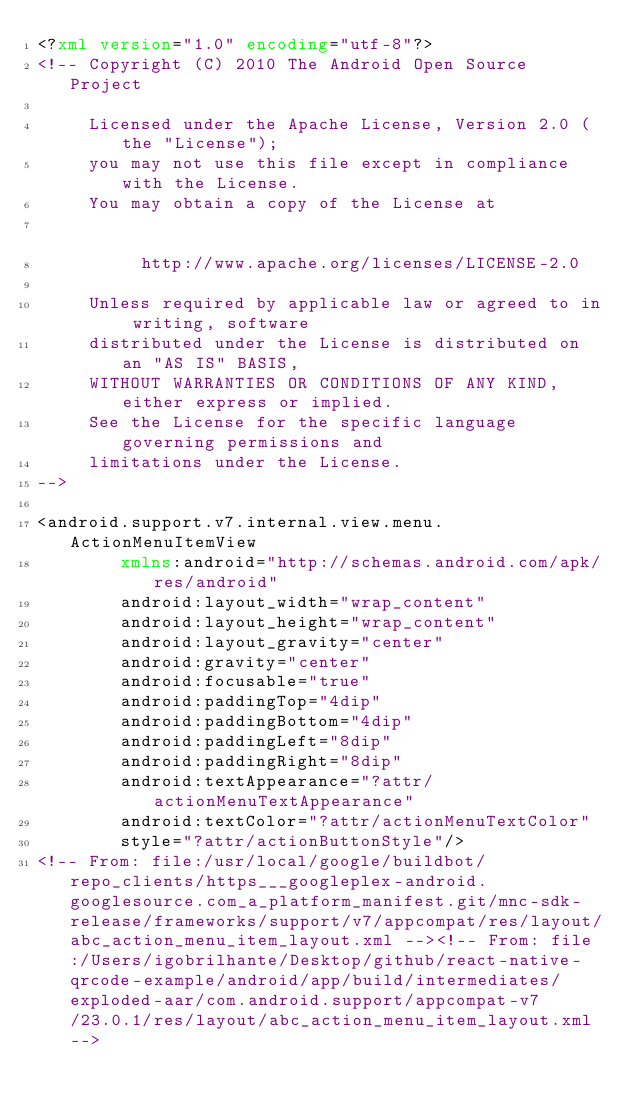Convert code to text. <code><loc_0><loc_0><loc_500><loc_500><_XML_><?xml version="1.0" encoding="utf-8"?>
<!-- Copyright (C) 2010 The Android Open Source Project

     Licensed under the Apache License, Version 2.0 (the "License");
     you may not use this file except in compliance with the License.
     You may obtain a copy of the License at
                                                          dd
          http://www.apache.org/licenses/LICENSE-2.0
  
     Unless required by applicable law or agreed to in writing, software
     distributed under the License is distributed on an "AS IS" BASIS,
     WITHOUT WARRANTIES OR CONDITIONS OF ANY KIND, either express or implied.
     See the License for the specific language governing permissions and
     limitations under the License.
-->

<android.support.v7.internal.view.menu.ActionMenuItemView
        xmlns:android="http://schemas.android.com/apk/res/android"
        android:layout_width="wrap_content"
        android:layout_height="wrap_content"
        android:layout_gravity="center"
        android:gravity="center"
        android:focusable="true"
        android:paddingTop="4dip"
        android:paddingBottom="4dip"
        android:paddingLeft="8dip"
        android:paddingRight="8dip"
        android:textAppearance="?attr/actionMenuTextAppearance"
        android:textColor="?attr/actionMenuTextColor"
        style="?attr/actionButtonStyle"/>
<!-- From: file:/usr/local/google/buildbot/repo_clients/https___googleplex-android.googlesource.com_a_platform_manifest.git/mnc-sdk-release/frameworks/support/v7/appcompat/res/layout/abc_action_menu_item_layout.xml --><!-- From: file:/Users/igobrilhante/Desktop/github/react-native-qrcode-example/android/app/build/intermediates/exploded-aar/com.android.support/appcompat-v7/23.0.1/res/layout/abc_action_menu_item_layout.xml --></code> 